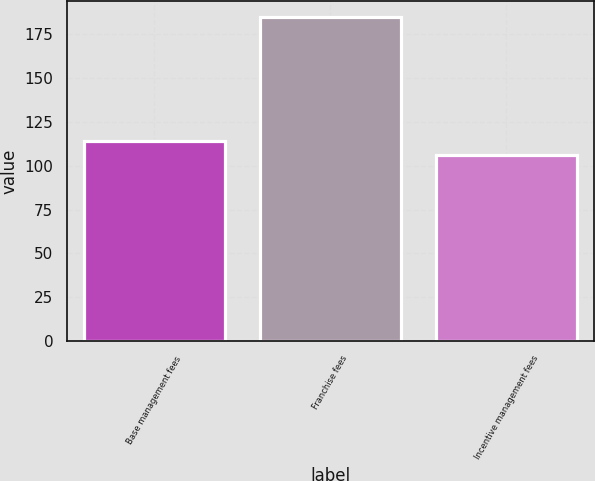<chart> <loc_0><loc_0><loc_500><loc_500><bar_chart><fcel>Base management fees<fcel>Franchise fees<fcel>Incentive management fees<nl><fcel>113.9<fcel>185<fcel>106<nl></chart> 